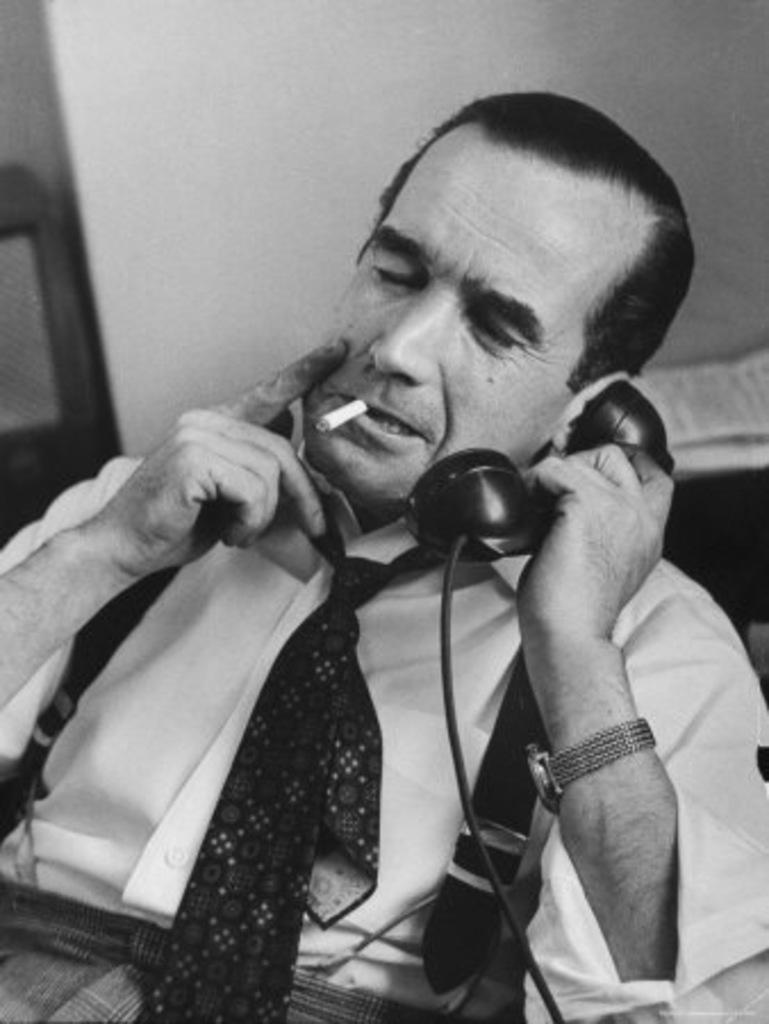What is the main subject of the image? There is a person in the image. What is the person doing in the image? The person is sitting. What object is the person holding in the image? The person is holding a telephone. What is the person doing with his mouth in the image? The person has a cigar in his mouth. What type of current is flowing through the telephone in the image? There is no information about the type of current flowing through the telephone in the image. Additionally, the image does not show any electrical components or wires that would allow us to determine the type of current. 